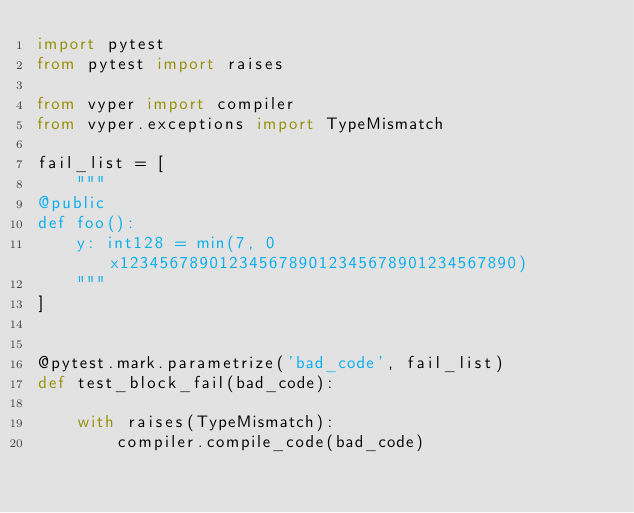<code> <loc_0><loc_0><loc_500><loc_500><_Python_>import pytest
from pytest import raises

from vyper import compiler
from vyper.exceptions import TypeMismatch

fail_list = [
    """
@public
def foo():
    y: int128 = min(7, 0x1234567890123456789012345678901234567890)
    """
]


@pytest.mark.parametrize('bad_code', fail_list)
def test_block_fail(bad_code):

    with raises(TypeMismatch):
        compiler.compile_code(bad_code)
</code> 